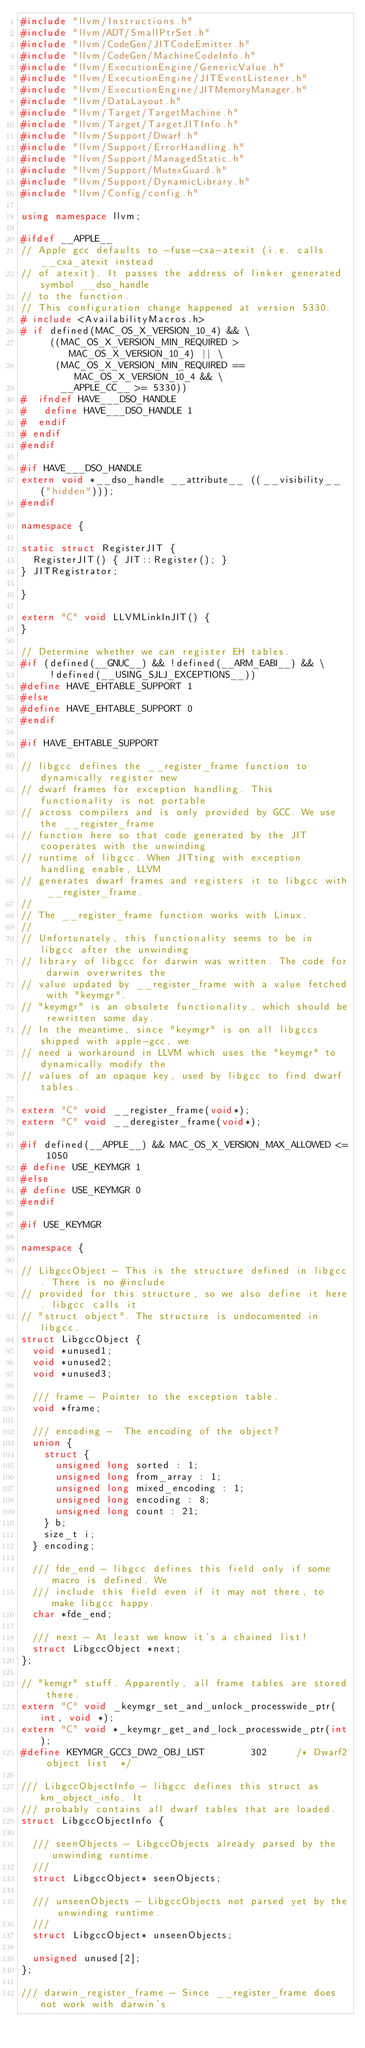<code> <loc_0><loc_0><loc_500><loc_500><_C++_>#include "llvm/Instructions.h"
#include "llvm/ADT/SmallPtrSet.h"
#include "llvm/CodeGen/JITCodeEmitter.h"
#include "llvm/CodeGen/MachineCodeInfo.h"
#include "llvm/ExecutionEngine/GenericValue.h"
#include "llvm/ExecutionEngine/JITEventListener.h"
#include "llvm/ExecutionEngine/JITMemoryManager.h"
#include "llvm/DataLayout.h"
#include "llvm/Target/TargetMachine.h"
#include "llvm/Target/TargetJITInfo.h"
#include "llvm/Support/Dwarf.h"
#include "llvm/Support/ErrorHandling.h"
#include "llvm/Support/ManagedStatic.h"
#include "llvm/Support/MutexGuard.h"
#include "llvm/Support/DynamicLibrary.h"
#include "llvm/Config/config.h"

using namespace llvm;

#ifdef __APPLE__
// Apple gcc defaults to -fuse-cxa-atexit (i.e. calls __cxa_atexit instead
// of atexit). It passes the address of linker generated symbol __dso_handle
// to the function.
// This configuration change happened at version 5330.
# include <AvailabilityMacros.h>
# if defined(MAC_OS_X_VERSION_10_4) && \
     ((MAC_OS_X_VERSION_MIN_REQUIRED > MAC_OS_X_VERSION_10_4) || \
      (MAC_OS_X_VERSION_MIN_REQUIRED == MAC_OS_X_VERSION_10_4 && \
       __APPLE_CC__ >= 5330))
#  ifndef HAVE___DSO_HANDLE
#   define HAVE___DSO_HANDLE 1
#  endif
# endif
#endif

#if HAVE___DSO_HANDLE
extern void *__dso_handle __attribute__ ((__visibility__ ("hidden")));
#endif

namespace {

static struct RegisterJIT {
  RegisterJIT() { JIT::Register(); }
} JITRegistrator;

}

extern "C" void LLVMLinkInJIT() {
}

// Determine whether we can register EH tables.
#if (defined(__GNUC__) && !defined(__ARM_EABI__) && \
     !defined(__USING_SJLJ_EXCEPTIONS__))
#define HAVE_EHTABLE_SUPPORT 1
#else
#define HAVE_EHTABLE_SUPPORT 0
#endif

#if HAVE_EHTABLE_SUPPORT

// libgcc defines the __register_frame function to dynamically register new
// dwarf frames for exception handling. This functionality is not portable
// across compilers and is only provided by GCC. We use the __register_frame
// function here so that code generated by the JIT cooperates with the unwinding
// runtime of libgcc. When JITting with exception handling enable, LLVM
// generates dwarf frames and registers it to libgcc with __register_frame.
//
// The __register_frame function works with Linux.
//
// Unfortunately, this functionality seems to be in libgcc after the unwinding
// library of libgcc for darwin was written. The code for darwin overwrites the
// value updated by __register_frame with a value fetched with "keymgr".
// "keymgr" is an obsolete functionality, which should be rewritten some day.
// In the meantime, since "keymgr" is on all libgccs shipped with apple-gcc, we
// need a workaround in LLVM which uses the "keymgr" to dynamically modify the
// values of an opaque key, used by libgcc to find dwarf tables.

extern "C" void __register_frame(void*);
extern "C" void __deregister_frame(void*);

#if defined(__APPLE__) && MAC_OS_X_VERSION_MAX_ALLOWED <= 1050
# define USE_KEYMGR 1
#else
# define USE_KEYMGR 0
#endif

#if USE_KEYMGR

namespace {

// LibgccObject - This is the structure defined in libgcc. There is no #include
// provided for this structure, so we also define it here. libgcc calls it
// "struct object". The structure is undocumented in libgcc.
struct LibgccObject {
  void *unused1;
  void *unused2;
  void *unused3;

  /// frame - Pointer to the exception table.
  void *frame;

  /// encoding -  The encoding of the object?
  union {
    struct {
      unsigned long sorted : 1;
      unsigned long from_array : 1;
      unsigned long mixed_encoding : 1;
      unsigned long encoding : 8;
      unsigned long count : 21;
    } b;
    size_t i;
  } encoding;

  /// fde_end - libgcc defines this field only if some macro is defined. We
  /// include this field even if it may not there, to make libgcc happy.
  char *fde_end;

  /// next - At least we know it's a chained list!
  struct LibgccObject *next;
};

// "kemgr" stuff. Apparently, all frame tables are stored there.
extern "C" void _keymgr_set_and_unlock_processwide_ptr(int, void *);
extern "C" void *_keymgr_get_and_lock_processwide_ptr(int);
#define KEYMGR_GCC3_DW2_OBJ_LIST        302     /* Dwarf2 object list  */

/// LibgccObjectInfo - libgcc defines this struct as km_object_info. It
/// probably contains all dwarf tables that are loaded.
struct LibgccObjectInfo {

  /// seenObjects - LibgccObjects already parsed by the unwinding runtime.
  ///
  struct LibgccObject* seenObjects;

  /// unseenObjects - LibgccObjects not parsed yet by the unwinding runtime.
  ///
  struct LibgccObject* unseenObjects;

  unsigned unused[2];
};

/// darwin_register_frame - Since __register_frame does not work with darwin's</code> 